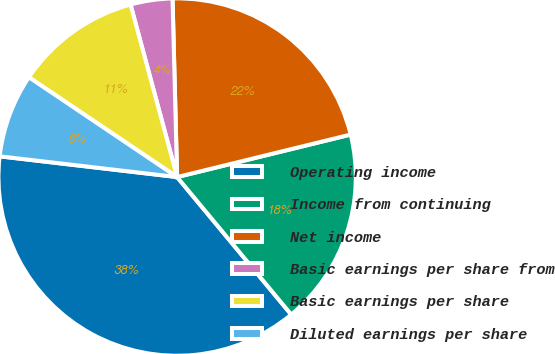<chart> <loc_0><loc_0><loc_500><loc_500><pie_chart><fcel>Operating income<fcel>Income from continuing<fcel>Net income<fcel>Basic earnings per share from<fcel>Basic earnings per share<fcel>Diluted earnings per share<nl><fcel>37.88%<fcel>17.8%<fcel>21.59%<fcel>3.79%<fcel>11.37%<fcel>7.58%<nl></chart> 